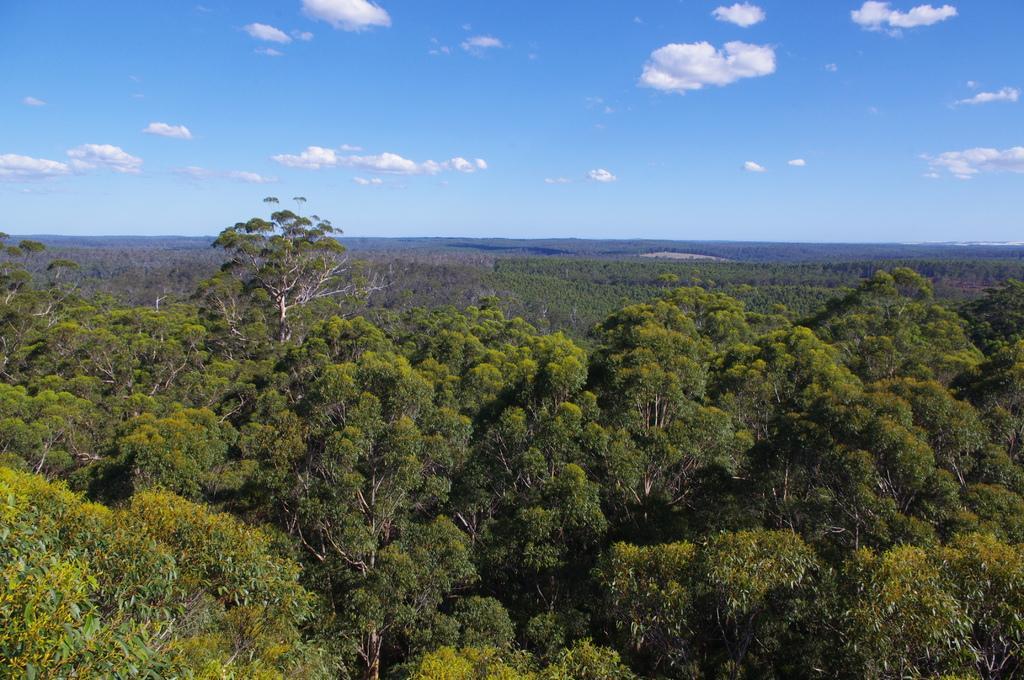Describe this image in one or two sentences. In this picture we can see trees and in the background we can see the sky with clouds. 